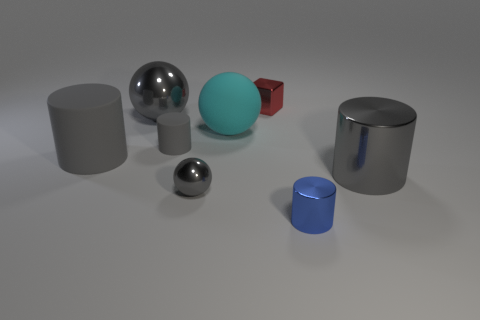The other metallic ball that is the same color as the big metal sphere is what size?
Make the answer very short. Small. What number of cubes are big gray matte things or big gray things?
Provide a succinct answer. 0. There is a gray object that is to the right of the big cyan matte object; is it the same shape as the big cyan rubber object?
Your answer should be compact. No. Are there more small shiny objects that are in front of the small shiny cylinder than large cyan metallic things?
Make the answer very short. No. There is a sphere that is the same size as the block; what color is it?
Keep it short and to the point. Gray. How many things are either gray metal objects that are behind the tiny ball or blue cylinders?
Provide a short and direct response. 3. There is a small matte object that is the same color as the small ball; what is its shape?
Your answer should be compact. Cylinder. There is a small cylinder that is to the left of the small gray object that is in front of the small gray cylinder; what is it made of?
Your answer should be compact. Rubber. Is there a gray cylinder made of the same material as the red object?
Provide a short and direct response. Yes. There is a big gray cylinder to the left of the tiny red thing; are there any gray spheres behind it?
Make the answer very short. Yes. 